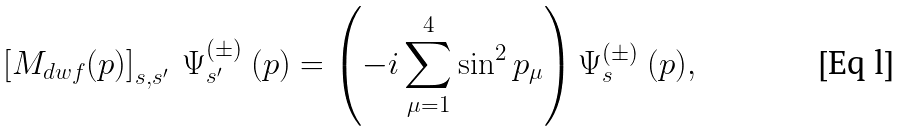Convert formula to latex. <formula><loc_0><loc_0><loc_500><loc_500>\left [ M _ { d w f } ( p ) \right ] _ { s , s ^ { \prime } } \ \Psi ^ { ( \pm ) } _ { s ^ { \prime } } \ ( p ) = \left ( - i \sum _ { \mu = 1 } ^ { 4 } \sin ^ { 2 } p _ { \mu } \right ) \Psi ^ { ( \pm ) } _ { s } \ ( p ) ,</formula> 